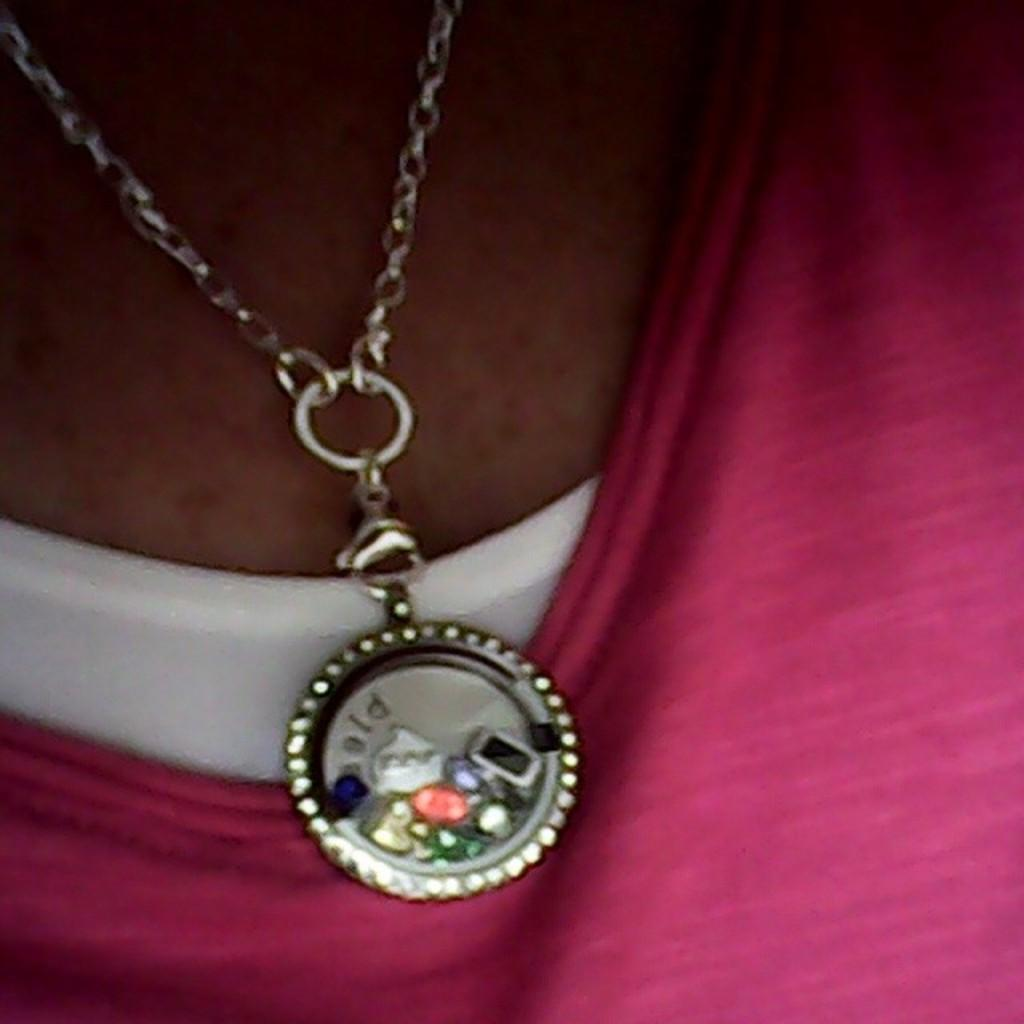What is the main subject of the image? There is a person in the image. Can you describe the person's attire? The person is wearing a pink and white color dress. What accessory is the person wearing around their neck? There is a chain with a locket around the person's neck. What type of toothpaste is the person using in the image? There is no toothpaste present in the image. Can you describe the jellyfish swimming near the person in the image? There are no jellyfish present in the image; it only features a person wearing a dress and a locket. 